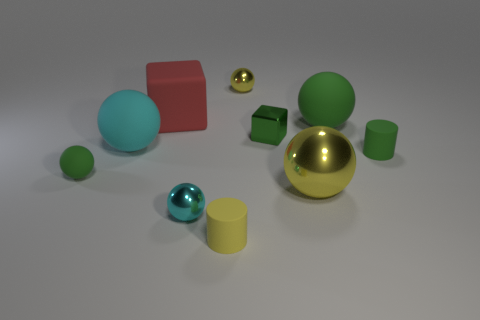Are there any tiny shiny objects that have the same color as the big shiny sphere?
Keep it short and to the point. Yes. There is a rubber cylinder that is the same color as the metal block; what size is it?
Offer a very short reply. Small. What is the material of the big thing that is the same color as the tiny block?
Make the answer very short. Rubber. There is a ball that is in front of the cyan rubber object and behind the big yellow metal sphere; what size is it?
Your answer should be very brief. Small. What number of matte objects are big things or green balls?
Offer a terse response. 4. Is the number of big rubber blocks that are to the left of the big cyan rubber object greater than the number of big cubes?
Make the answer very short. No. What is the material of the tiny object in front of the tiny cyan thing?
Ensure brevity in your answer.  Rubber. What number of tiny yellow spheres have the same material as the small cyan thing?
Provide a short and direct response. 1. There is a large object that is both in front of the large green matte sphere and behind the tiny green rubber cylinder; what shape is it?
Your answer should be compact. Sphere. What number of things are tiny cyan spheres left of the green cylinder or green spheres to the right of the red rubber block?
Your answer should be very brief. 2. 